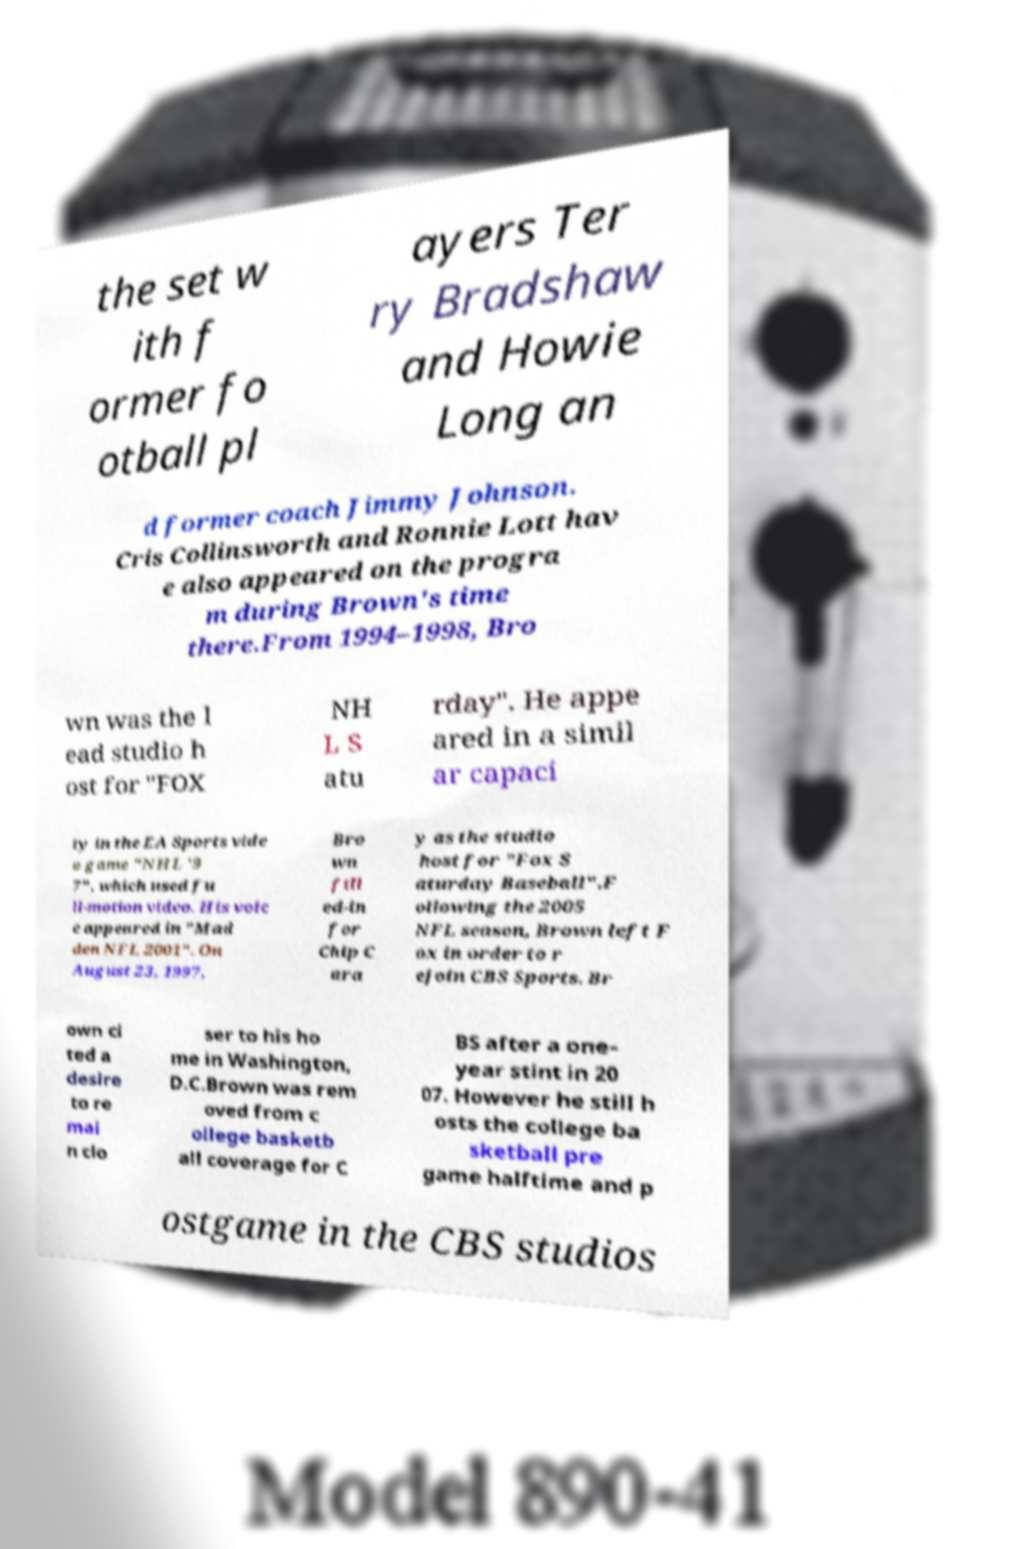There's text embedded in this image that I need extracted. Can you transcribe it verbatim? the set w ith f ormer fo otball pl ayers Ter ry Bradshaw and Howie Long an d former coach Jimmy Johnson. Cris Collinsworth and Ronnie Lott hav e also appeared on the progra m during Brown's time there.From 1994–1998, Bro wn was the l ead studio h ost for "FOX NH L S atu rday". He appe ared in a simil ar capaci ty in the EA Sports vide o game "NHL '9 7", which used fu ll-motion video. His voic e appeared in "Mad den NFL 2001". On August 23, 1997, Bro wn fill ed-in for Chip C ara y as the studio host for "Fox S aturday Baseball".F ollowing the 2005 NFL season, Brown left F ox in order to r ejoin CBS Sports. Br own ci ted a desire to re mai n clo ser to his ho me in Washington, D.C.Brown was rem oved from c ollege basketb all coverage for C BS after a one- year stint in 20 07. However he still h osts the college ba sketball pre game halftime and p ostgame in the CBS studios 